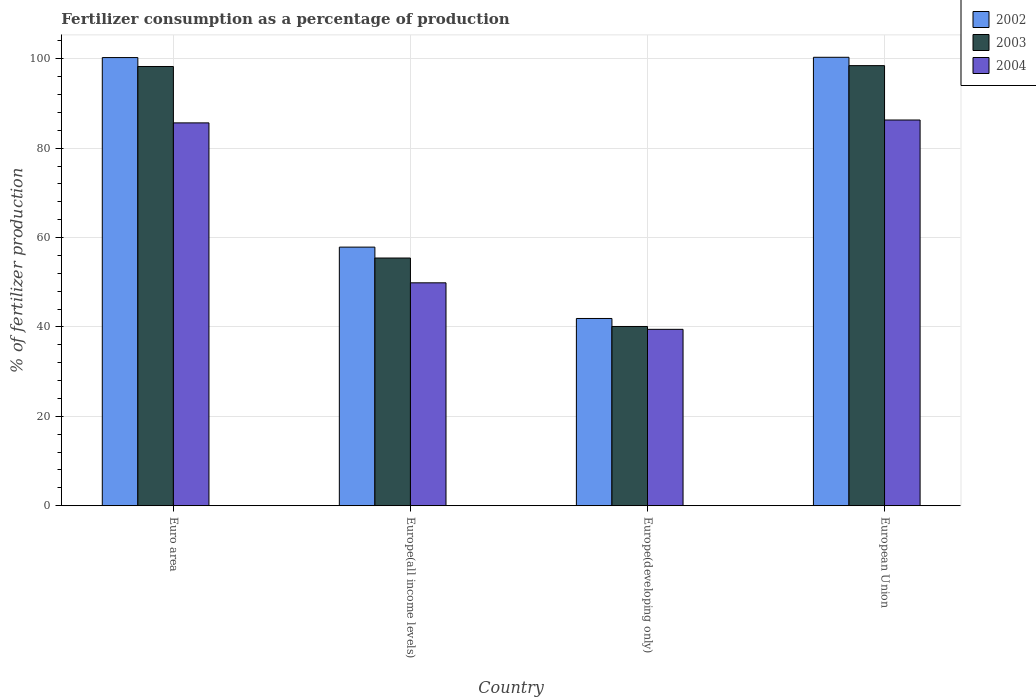How many groups of bars are there?
Give a very brief answer. 4. Are the number of bars on each tick of the X-axis equal?
Make the answer very short. Yes. What is the label of the 3rd group of bars from the left?
Keep it short and to the point. Europe(developing only). What is the percentage of fertilizers consumed in 2003 in Europe(all income levels)?
Offer a terse response. 55.43. Across all countries, what is the maximum percentage of fertilizers consumed in 2002?
Provide a short and direct response. 100.34. Across all countries, what is the minimum percentage of fertilizers consumed in 2003?
Offer a very short reply. 40.11. In which country was the percentage of fertilizers consumed in 2003 maximum?
Provide a succinct answer. European Union. In which country was the percentage of fertilizers consumed in 2003 minimum?
Provide a short and direct response. Europe(developing only). What is the total percentage of fertilizers consumed in 2003 in the graph?
Give a very brief answer. 292.3. What is the difference between the percentage of fertilizers consumed in 2003 in Europe(developing only) and that in European Union?
Keep it short and to the point. -58.37. What is the difference between the percentage of fertilizers consumed in 2002 in Europe(all income levels) and the percentage of fertilizers consumed in 2004 in Euro area?
Provide a succinct answer. -27.8. What is the average percentage of fertilizers consumed in 2003 per country?
Provide a succinct answer. 73.08. What is the difference between the percentage of fertilizers consumed of/in 2004 and percentage of fertilizers consumed of/in 2003 in Euro area?
Offer a terse response. -12.62. What is the ratio of the percentage of fertilizers consumed in 2003 in Europe(all income levels) to that in Europe(developing only)?
Your response must be concise. 1.38. What is the difference between the highest and the second highest percentage of fertilizers consumed in 2003?
Your response must be concise. 0.19. What is the difference between the highest and the lowest percentage of fertilizers consumed in 2004?
Offer a very short reply. 46.84. What does the 3rd bar from the right in European Union represents?
Make the answer very short. 2002. Is it the case that in every country, the sum of the percentage of fertilizers consumed in 2004 and percentage of fertilizers consumed in 2002 is greater than the percentage of fertilizers consumed in 2003?
Ensure brevity in your answer.  Yes. Are all the bars in the graph horizontal?
Provide a succinct answer. No. How many countries are there in the graph?
Ensure brevity in your answer.  4. Are the values on the major ticks of Y-axis written in scientific E-notation?
Keep it short and to the point. No. Does the graph contain grids?
Offer a terse response. Yes. Where does the legend appear in the graph?
Ensure brevity in your answer.  Top right. How many legend labels are there?
Your answer should be compact. 3. How are the legend labels stacked?
Offer a terse response. Vertical. What is the title of the graph?
Keep it short and to the point. Fertilizer consumption as a percentage of production. What is the label or title of the X-axis?
Your answer should be compact. Country. What is the label or title of the Y-axis?
Your answer should be compact. % of fertilizer production. What is the % of fertilizer production of 2002 in Euro area?
Provide a short and direct response. 100.28. What is the % of fertilizer production in 2003 in Euro area?
Give a very brief answer. 98.29. What is the % of fertilizer production of 2004 in Euro area?
Ensure brevity in your answer.  85.67. What is the % of fertilizer production of 2002 in Europe(all income levels)?
Provide a succinct answer. 57.87. What is the % of fertilizer production in 2003 in Europe(all income levels)?
Provide a short and direct response. 55.43. What is the % of fertilizer production of 2004 in Europe(all income levels)?
Provide a short and direct response. 49.88. What is the % of fertilizer production in 2002 in Europe(developing only)?
Your answer should be very brief. 41.9. What is the % of fertilizer production in 2003 in Europe(developing only)?
Your response must be concise. 40.11. What is the % of fertilizer production of 2004 in Europe(developing only)?
Your response must be concise. 39.47. What is the % of fertilizer production in 2002 in European Union?
Ensure brevity in your answer.  100.34. What is the % of fertilizer production in 2003 in European Union?
Keep it short and to the point. 98.48. What is the % of fertilizer production in 2004 in European Union?
Ensure brevity in your answer.  86.31. Across all countries, what is the maximum % of fertilizer production of 2002?
Keep it short and to the point. 100.34. Across all countries, what is the maximum % of fertilizer production in 2003?
Your answer should be compact. 98.48. Across all countries, what is the maximum % of fertilizer production of 2004?
Your answer should be very brief. 86.31. Across all countries, what is the minimum % of fertilizer production in 2002?
Provide a short and direct response. 41.9. Across all countries, what is the minimum % of fertilizer production in 2003?
Provide a short and direct response. 40.11. Across all countries, what is the minimum % of fertilizer production of 2004?
Keep it short and to the point. 39.47. What is the total % of fertilizer production of 2002 in the graph?
Your answer should be compact. 300.39. What is the total % of fertilizer production in 2003 in the graph?
Ensure brevity in your answer.  292.3. What is the total % of fertilizer production in 2004 in the graph?
Your answer should be very brief. 261.33. What is the difference between the % of fertilizer production in 2002 in Euro area and that in Europe(all income levels)?
Provide a succinct answer. 42.42. What is the difference between the % of fertilizer production in 2003 in Euro area and that in Europe(all income levels)?
Provide a succinct answer. 42.86. What is the difference between the % of fertilizer production in 2004 in Euro area and that in Europe(all income levels)?
Provide a succinct answer. 35.79. What is the difference between the % of fertilizer production in 2002 in Euro area and that in Europe(developing only)?
Make the answer very short. 58.38. What is the difference between the % of fertilizer production in 2003 in Euro area and that in Europe(developing only)?
Your response must be concise. 58.17. What is the difference between the % of fertilizer production of 2004 in Euro area and that in Europe(developing only)?
Your answer should be compact. 46.2. What is the difference between the % of fertilizer production in 2002 in Euro area and that in European Union?
Your response must be concise. -0.06. What is the difference between the % of fertilizer production in 2003 in Euro area and that in European Union?
Offer a very short reply. -0.19. What is the difference between the % of fertilizer production in 2004 in Euro area and that in European Union?
Your answer should be compact. -0.64. What is the difference between the % of fertilizer production of 2002 in Europe(all income levels) and that in Europe(developing only)?
Give a very brief answer. 15.97. What is the difference between the % of fertilizer production in 2003 in Europe(all income levels) and that in Europe(developing only)?
Your response must be concise. 15.32. What is the difference between the % of fertilizer production of 2004 in Europe(all income levels) and that in Europe(developing only)?
Your answer should be very brief. 10.41. What is the difference between the % of fertilizer production in 2002 in Europe(all income levels) and that in European Union?
Provide a short and direct response. -42.48. What is the difference between the % of fertilizer production of 2003 in Europe(all income levels) and that in European Union?
Keep it short and to the point. -43.05. What is the difference between the % of fertilizer production in 2004 in Europe(all income levels) and that in European Union?
Offer a very short reply. -36.43. What is the difference between the % of fertilizer production in 2002 in Europe(developing only) and that in European Union?
Provide a short and direct response. -58.44. What is the difference between the % of fertilizer production in 2003 in Europe(developing only) and that in European Union?
Provide a succinct answer. -58.37. What is the difference between the % of fertilizer production of 2004 in Europe(developing only) and that in European Union?
Offer a terse response. -46.84. What is the difference between the % of fertilizer production of 2002 in Euro area and the % of fertilizer production of 2003 in Europe(all income levels)?
Offer a very short reply. 44.85. What is the difference between the % of fertilizer production in 2002 in Euro area and the % of fertilizer production in 2004 in Europe(all income levels)?
Provide a short and direct response. 50.4. What is the difference between the % of fertilizer production in 2003 in Euro area and the % of fertilizer production in 2004 in Europe(all income levels)?
Provide a succinct answer. 48.41. What is the difference between the % of fertilizer production in 2002 in Euro area and the % of fertilizer production in 2003 in Europe(developing only)?
Make the answer very short. 60.17. What is the difference between the % of fertilizer production in 2002 in Euro area and the % of fertilizer production in 2004 in Europe(developing only)?
Provide a succinct answer. 60.81. What is the difference between the % of fertilizer production in 2003 in Euro area and the % of fertilizer production in 2004 in Europe(developing only)?
Provide a short and direct response. 58.81. What is the difference between the % of fertilizer production of 2002 in Euro area and the % of fertilizer production of 2003 in European Union?
Offer a terse response. 1.8. What is the difference between the % of fertilizer production of 2002 in Euro area and the % of fertilizer production of 2004 in European Union?
Keep it short and to the point. 13.97. What is the difference between the % of fertilizer production in 2003 in Euro area and the % of fertilizer production in 2004 in European Union?
Give a very brief answer. 11.98. What is the difference between the % of fertilizer production in 2002 in Europe(all income levels) and the % of fertilizer production in 2003 in Europe(developing only)?
Keep it short and to the point. 17.76. What is the difference between the % of fertilizer production in 2002 in Europe(all income levels) and the % of fertilizer production in 2004 in Europe(developing only)?
Offer a terse response. 18.39. What is the difference between the % of fertilizer production in 2003 in Europe(all income levels) and the % of fertilizer production in 2004 in Europe(developing only)?
Your answer should be compact. 15.96. What is the difference between the % of fertilizer production of 2002 in Europe(all income levels) and the % of fertilizer production of 2003 in European Union?
Provide a succinct answer. -40.61. What is the difference between the % of fertilizer production in 2002 in Europe(all income levels) and the % of fertilizer production in 2004 in European Union?
Give a very brief answer. -28.44. What is the difference between the % of fertilizer production in 2003 in Europe(all income levels) and the % of fertilizer production in 2004 in European Union?
Offer a terse response. -30.88. What is the difference between the % of fertilizer production of 2002 in Europe(developing only) and the % of fertilizer production of 2003 in European Union?
Your answer should be compact. -56.58. What is the difference between the % of fertilizer production in 2002 in Europe(developing only) and the % of fertilizer production in 2004 in European Union?
Provide a short and direct response. -44.41. What is the difference between the % of fertilizer production in 2003 in Europe(developing only) and the % of fertilizer production in 2004 in European Union?
Your answer should be compact. -46.2. What is the average % of fertilizer production of 2002 per country?
Provide a succinct answer. 75.1. What is the average % of fertilizer production in 2003 per country?
Your response must be concise. 73.08. What is the average % of fertilizer production in 2004 per country?
Your answer should be very brief. 65.33. What is the difference between the % of fertilizer production of 2002 and % of fertilizer production of 2003 in Euro area?
Offer a terse response. 2. What is the difference between the % of fertilizer production of 2002 and % of fertilizer production of 2004 in Euro area?
Ensure brevity in your answer.  14.61. What is the difference between the % of fertilizer production of 2003 and % of fertilizer production of 2004 in Euro area?
Your answer should be compact. 12.62. What is the difference between the % of fertilizer production in 2002 and % of fertilizer production in 2003 in Europe(all income levels)?
Your response must be concise. 2.44. What is the difference between the % of fertilizer production of 2002 and % of fertilizer production of 2004 in Europe(all income levels)?
Offer a terse response. 7.99. What is the difference between the % of fertilizer production of 2003 and % of fertilizer production of 2004 in Europe(all income levels)?
Your answer should be compact. 5.55. What is the difference between the % of fertilizer production of 2002 and % of fertilizer production of 2003 in Europe(developing only)?
Your answer should be compact. 1.79. What is the difference between the % of fertilizer production of 2002 and % of fertilizer production of 2004 in Europe(developing only)?
Provide a short and direct response. 2.43. What is the difference between the % of fertilizer production of 2003 and % of fertilizer production of 2004 in Europe(developing only)?
Your answer should be very brief. 0.64. What is the difference between the % of fertilizer production of 2002 and % of fertilizer production of 2003 in European Union?
Offer a very short reply. 1.86. What is the difference between the % of fertilizer production of 2002 and % of fertilizer production of 2004 in European Union?
Your answer should be compact. 14.03. What is the difference between the % of fertilizer production in 2003 and % of fertilizer production in 2004 in European Union?
Make the answer very short. 12.17. What is the ratio of the % of fertilizer production of 2002 in Euro area to that in Europe(all income levels)?
Offer a very short reply. 1.73. What is the ratio of the % of fertilizer production in 2003 in Euro area to that in Europe(all income levels)?
Ensure brevity in your answer.  1.77. What is the ratio of the % of fertilizer production of 2004 in Euro area to that in Europe(all income levels)?
Provide a succinct answer. 1.72. What is the ratio of the % of fertilizer production of 2002 in Euro area to that in Europe(developing only)?
Your answer should be compact. 2.39. What is the ratio of the % of fertilizer production of 2003 in Euro area to that in Europe(developing only)?
Give a very brief answer. 2.45. What is the ratio of the % of fertilizer production of 2004 in Euro area to that in Europe(developing only)?
Provide a short and direct response. 2.17. What is the ratio of the % of fertilizer production in 2002 in Euro area to that in European Union?
Make the answer very short. 1. What is the ratio of the % of fertilizer production of 2003 in Euro area to that in European Union?
Offer a very short reply. 1. What is the ratio of the % of fertilizer production of 2004 in Euro area to that in European Union?
Your response must be concise. 0.99. What is the ratio of the % of fertilizer production in 2002 in Europe(all income levels) to that in Europe(developing only)?
Make the answer very short. 1.38. What is the ratio of the % of fertilizer production of 2003 in Europe(all income levels) to that in Europe(developing only)?
Offer a terse response. 1.38. What is the ratio of the % of fertilizer production in 2004 in Europe(all income levels) to that in Europe(developing only)?
Your response must be concise. 1.26. What is the ratio of the % of fertilizer production in 2002 in Europe(all income levels) to that in European Union?
Your answer should be compact. 0.58. What is the ratio of the % of fertilizer production of 2003 in Europe(all income levels) to that in European Union?
Provide a succinct answer. 0.56. What is the ratio of the % of fertilizer production of 2004 in Europe(all income levels) to that in European Union?
Your response must be concise. 0.58. What is the ratio of the % of fertilizer production in 2002 in Europe(developing only) to that in European Union?
Give a very brief answer. 0.42. What is the ratio of the % of fertilizer production of 2003 in Europe(developing only) to that in European Union?
Your answer should be compact. 0.41. What is the ratio of the % of fertilizer production in 2004 in Europe(developing only) to that in European Union?
Your response must be concise. 0.46. What is the difference between the highest and the second highest % of fertilizer production of 2002?
Offer a terse response. 0.06. What is the difference between the highest and the second highest % of fertilizer production in 2003?
Give a very brief answer. 0.19. What is the difference between the highest and the second highest % of fertilizer production of 2004?
Provide a succinct answer. 0.64. What is the difference between the highest and the lowest % of fertilizer production in 2002?
Your answer should be very brief. 58.44. What is the difference between the highest and the lowest % of fertilizer production in 2003?
Provide a short and direct response. 58.37. What is the difference between the highest and the lowest % of fertilizer production in 2004?
Offer a terse response. 46.84. 